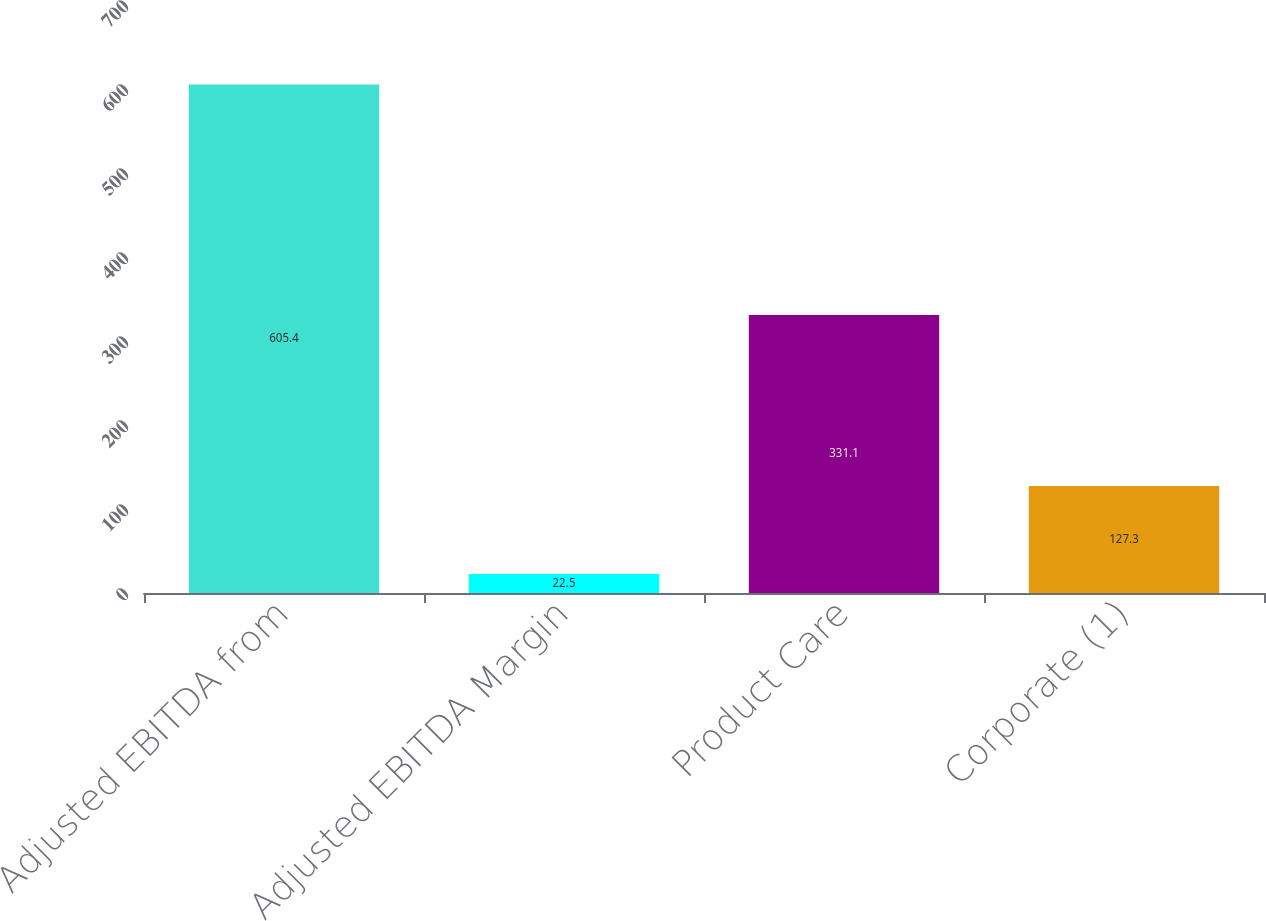Convert chart. <chart><loc_0><loc_0><loc_500><loc_500><bar_chart><fcel>Adjusted EBITDA from<fcel>Adjusted EBITDA Margin<fcel>Product Care<fcel>Corporate (1)<nl><fcel>605.4<fcel>22.5<fcel>331.1<fcel>127.3<nl></chart> 